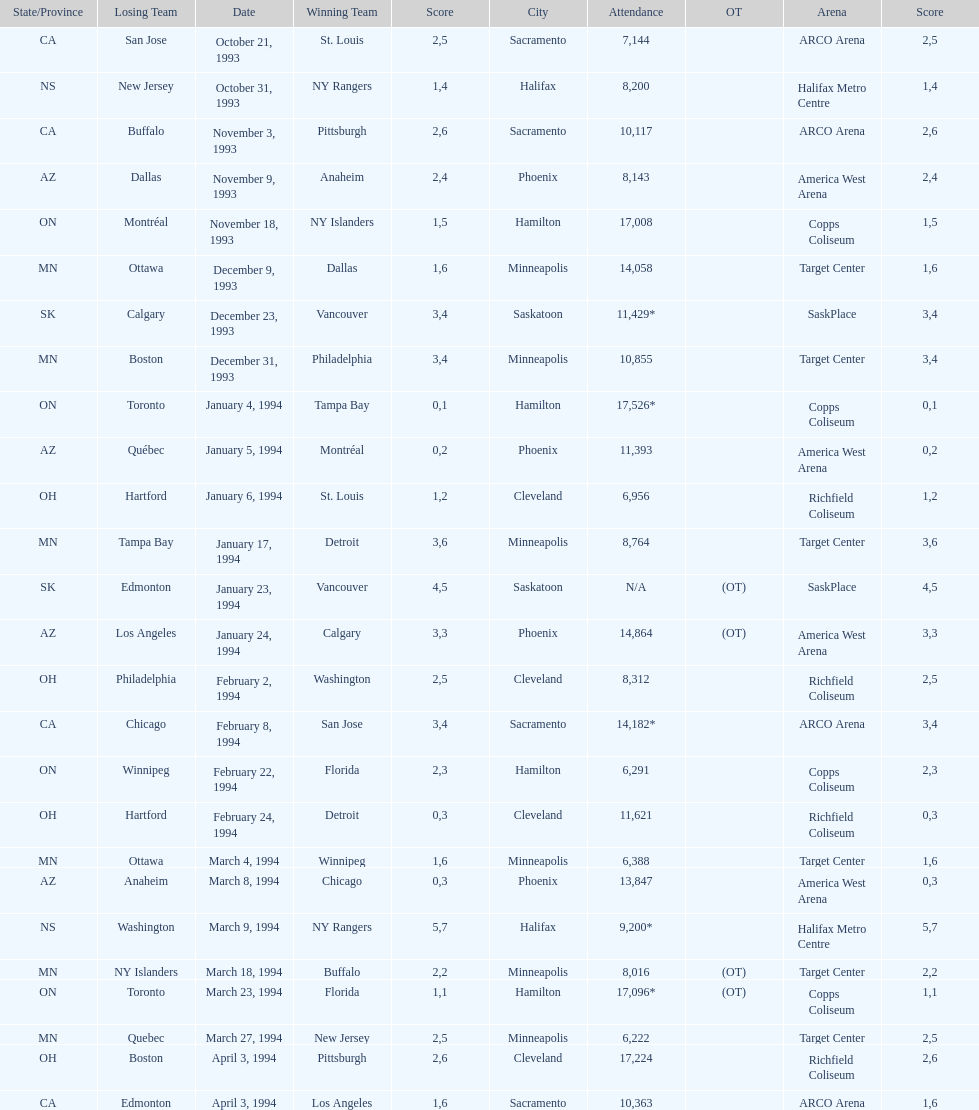Which event had higher attendance, january 24, 1994, or december 23, 1993? January 4, 1994. 